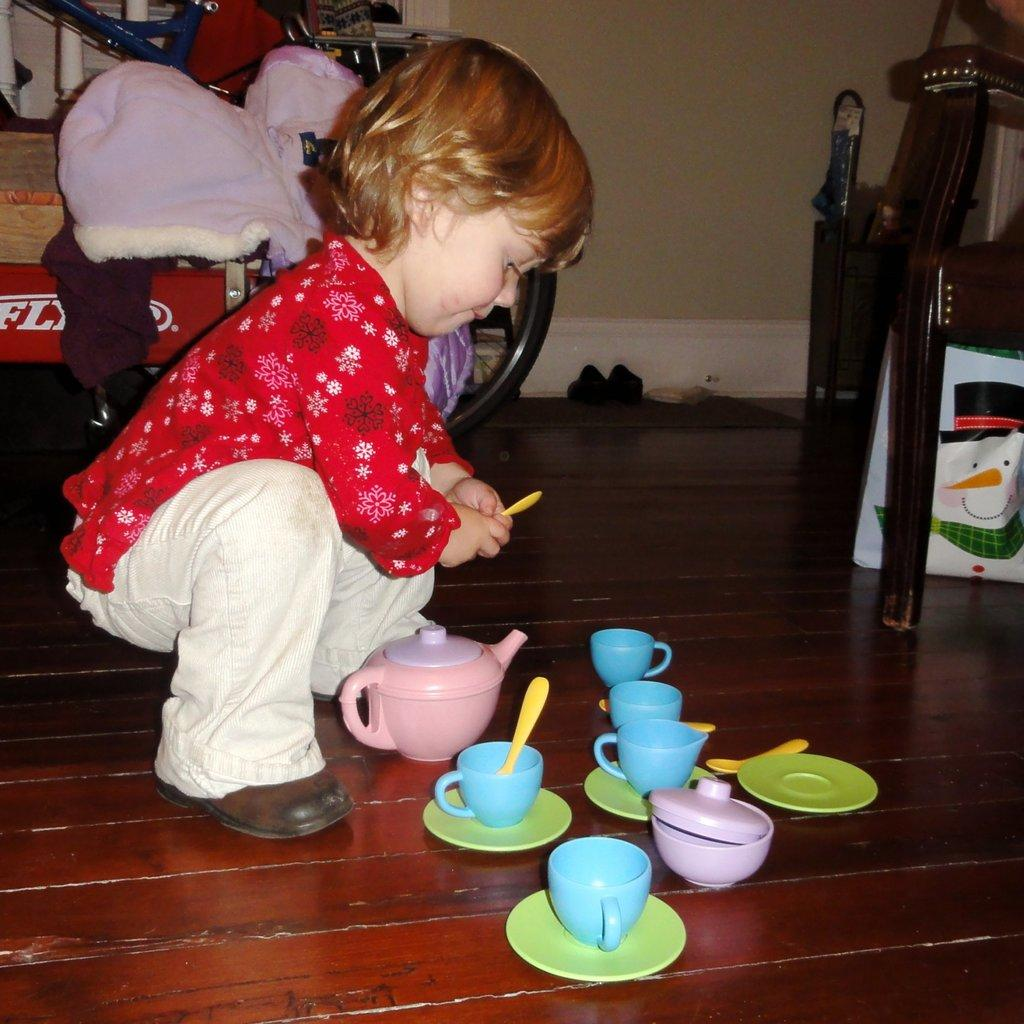What is the baby doing in the image? The baby is sitting on the floor in the image. What can be seen around the baby? There are toys and a bicycle in the image. What else is visible in the image? There are clothes and a wall in the image. What type of cap is the baby wearing in the image? There is no cap visible on the baby in the image. Can you tell me how the baby is feeling based on their temper in the image? The image does not provide any information about the baby's emotions or temper. 